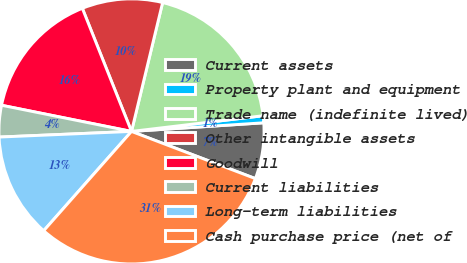Convert chart to OTSL. <chart><loc_0><loc_0><loc_500><loc_500><pie_chart><fcel>Current assets<fcel>Property plant and equipment<fcel>Trade name (indefinite lived)<fcel>Other intangible assets<fcel>Goodwill<fcel>Current liabilities<fcel>Long-term liabilities<fcel>Cash purchase price (net of<nl><fcel>6.83%<fcel>0.85%<fcel>19.34%<fcel>9.82%<fcel>15.79%<fcel>3.84%<fcel>12.8%<fcel>30.73%<nl></chart> 